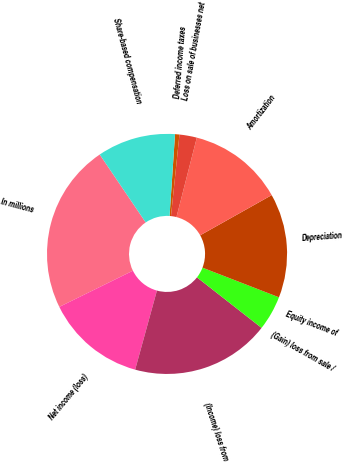Convert chart. <chart><loc_0><loc_0><loc_500><loc_500><pie_chart><fcel>In millions<fcel>Net income (loss)<fcel>(Income) loss from<fcel>(Gain) loss from sale /<fcel>Equity income of<fcel>Depreciation<fcel>Amortization<fcel>Loss on sale of businesses net<fcel>Deferred income taxes<fcel>Share-based compensation<nl><fcel>22.8%<fcel>13.45%<fcel>18.71%<fcel>4.68%<fcel>0.0%<fcel>14.03%<fcel>12.86%<fcel>2.34%<fcel>0.59%<fcel>10.53%<nl></chart> 